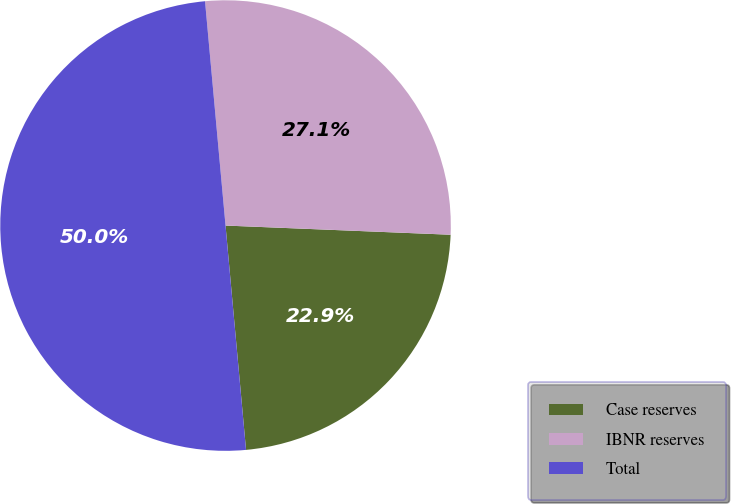Convert chart to OTSL. <chart><loc_0><loc_0><loc_500><loc_500><pie_chart><fcel>Case reserves<fcel>IBNR reserves<fcel>Total<nl><fcel>22.9%<fcel>27.1%<fcel>50.0%<nl></chart> 